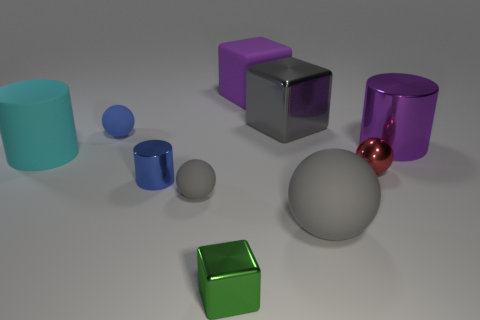What is the material of the ball behind the purple object that is right of the large gray object that is behind the purple cylinder?
Make the answer very short. Rubber. There is a cyan object; is its shape the same as the big gray object in front of the matte cylinder?
Offer a very short reply. No. How many other big cyan objects have the same shape as the cyan object?
Provide a short and direct response. 0. What is the shape of the cyan thing?
Your answer should be very brief. Cylinder. What is the size of the matte ball behind the blue object that is in front of the big purple cylinder?
Your answer should be compact. Small. What number of objects are green shiny objects or gray matte blocks?
Provide a succinct answer. 1. Is the gray shiny thing the same shape as the small red shiny object?
Give a very brief answer. No. Is there a tiny thing that has the same material as the big cyan thing?
Keep it short and to the point. Yes. Are there any large rubber cylinders that are to the right of the small gray sphere to the left of the tiny cube?
Provide a short and direct response. No. There is a gray rubber sphere to the right of the purple rubber block; is it the same size as the big metal cylinder?
Make the answer very short. Yes. 